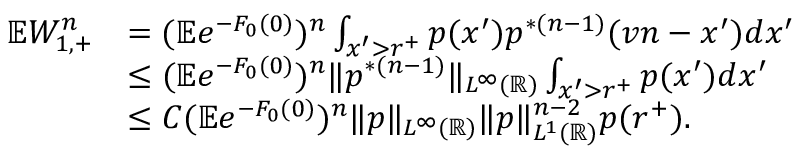Convert formula to latex. <formula><loc_0><loc_0><loc_500><loc_500>\begin{array} { r l } { \mathbb { E } W _ { 1 , + } ^ { n } } & { = ( \mathbb { E } e ^ { - F _ { 0 } ( 0 ) } ) ^ { n } \int _ { x ^ { \prime } > r ^ { + } } p ( x ^ { \prime } ) p ^ { \ast ( n - 1 ) } ( v n - x ^ { \prime } ) d x ^ { \prime } } \\ & { \leq ( \mathbb { E } e ^ { - F _ { 0 } ( 0 ) } ) ^ { n } \| p ^ { \ast ( n - 1 ) } \| _ { L ^ { \infty } ( \mathbb { R } ) } \int _ { x ^ { \prime } > r ^ { + } } p ( x ^ { \prime } ) d x ^ { \prime } } \\ & { \leq C ( \mathbb { E } e ^ { - F _ { 0 } ( 0 ) } ) ^ { n } \| p \| _ { L ^ { \infty } ( \mathbb { R } ) } \| p \| _ { L ^ { 1 } ( \mathbb { R } ) } ^ { n - 2 } p ( r ^ { + } ) . } \end{array}</formula> 